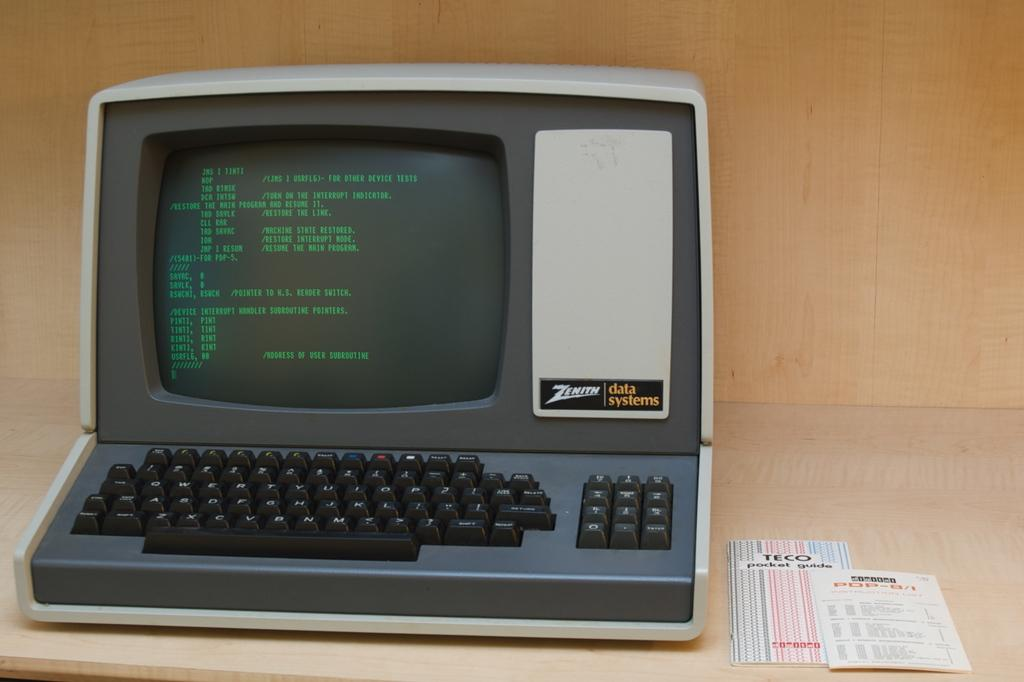<image>
Relay a brief, clear account of the picture shown. An old Zenith computer that is gray with black keys. 